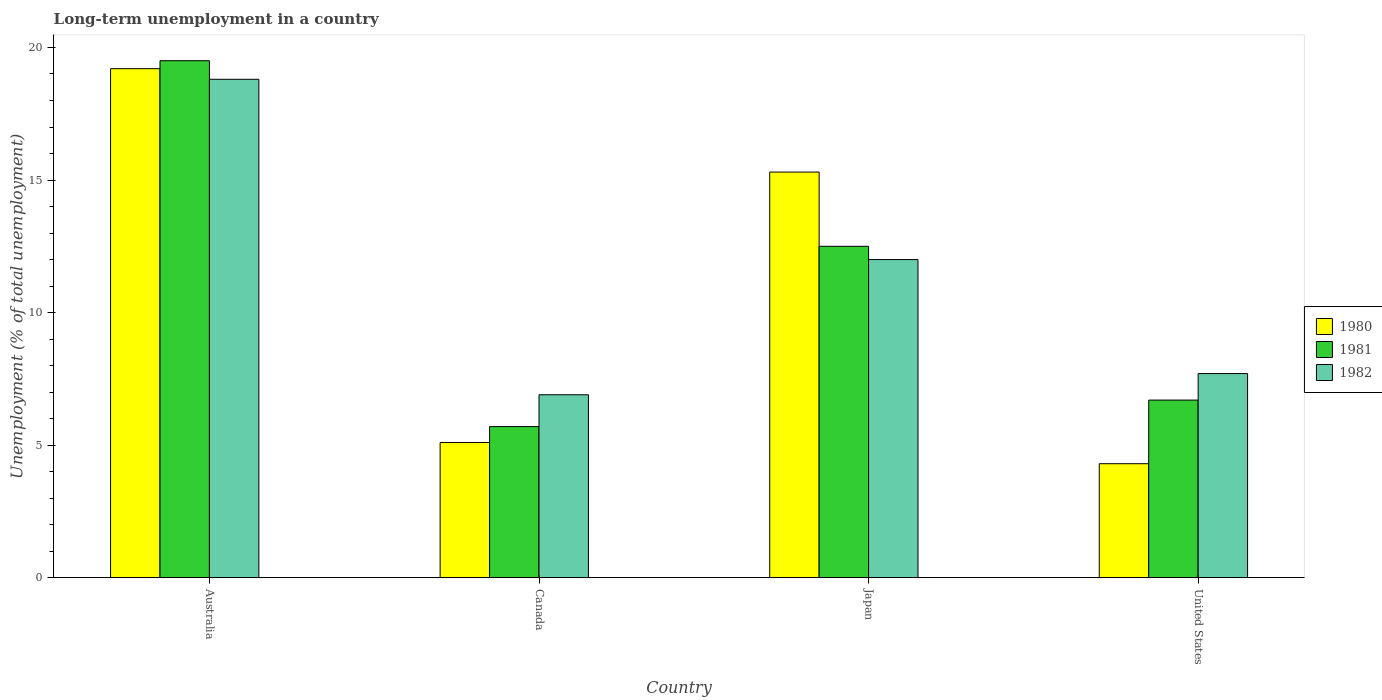How many different coloured bars are there?
Give a very brief answer. 3. How many groups of bars are there?
Provide a short and direct response. 4. Are the number of bars per tick equal to the number of legend labels?
Provide a short and direct response. Yes. How many bars are there on the 3rd tick from the left?
Your response must be concise. 3. How many bars are there on the 2nd tick from the right?
Give a very brief answer. 3. In how many cases, is the number of bars for a given country not equal to the number of legend labels?
Provide a short and direct response. 0. What is the percentage of long-term unemployed population in 1982 in Australia?
Offer a terse response. 18.8. Across all countries, what is the maximum percentage of long-term unemployed population in 1981?
Ensure brevity in your answer.  19.5. Across all countries, what is the minimum percentage of long-term unemployed population in 1981?
Offer a terse response. 5.7. What is the total percentage of long-term unemployed population in 1981 in the graph?
Your answer should be very brief. 44.4. What is the difference between the percentage of long-term unemployed population in 1982 in Canada and that in Japan?
Make the answer very short. -5.1. What is the difference between the percentage of long-term unemployed population in 1981 in Japan and the percentage of long-term unemployed population in 1982 in Canada?
Your answer should be very brief. 5.6. What is the average percentage of long-term unemployed population in 1982 per country?
Offer a very short reply. 11.35. What is the difference between the percentage of long-term unemployed population of/in 1982 and percentage of long-term unemployed population of/in 1980 in Canada?
Offer a very short reply. 1.8. In how many countries, is the percentage of long-term unemployed population in 1981 greater than 5 %?
Ensure brevity in your answer.  4. What is the ratio of the percentage of long-term unemployed population in 1981 in Australia to that in Japan?
Give a very brief answer. 1.56. Is the percentage of long-term unemployed population in 1982 in Australia less than that in Canada?
Your answer should be compact. No. What is the difference between the highest and the lowest percentage of long-term unemployed population in 1982?
Make the answer very short. 11.9. In how many countries, is the percentage of long-term unemployed population in 1981 greater than the average percentage of long-term unemployed population in 1981 taken over all countries?
Make the answer very short. 2. Is the sum of the percentage of long-term unemployed population in 1981 in Canada and United States greater than the maximum percentage of long-term unemployed population in 1980 across all countries?
Your answer should be very brief. No. What does the 2nd bar from the left in United States represents?
Your answer should be compact. 1981. Is it the case that in every country, the sum of the percentage of long-term unemployed population in 1981 and percentage of long-term unemployed population in 1982 is greater than the percentage of long-term unemployed population in 1980?
Offer a terse response. Yes. Are all the bars in the graph horizontal?
Offer a terse response. No. How many countries are there in the graph?
Give a very brief answer. 4. Are the values on the major ticks of Y-axis written in scientific E-notation?
Provide a short and direct response. No. Does the graph contain any zero values?
Your answer should be compact. No. Does the graph contain grids?
Your answer should be compact. No. Where does the legend appear in the graph?
Keep it short and to the point. Center right. How are the legend labels stacked?
Your response must be concise. Vertical. What is the title of the graph?
Offer a terse response. Long-term unemployment in a country. What is the label or title of the X-axis?
Offer a terse response. Country. What is the label or title of the Y-axis?
Your answer should be compact. Unemployment (% of total unemployment). What is the Unemployment (% of total unemployment) of 1980 in Australia?
Make the answer very short. 19.2. What is the Unemployment (% of total unemployment) of 1981 in Australia?
Make the answer very short. 19.5. What is the Unemployment (% of total unemployment) of 1982 in Australia?
Your answer should be compact. 18.8. What is the Unemployment (% of total unemployment) in 1980 in Canada?
Ensure brevity in your answer.  5.1. What is the Unemployment (% of total unemployment) in 1981 in Canada?
Provide a short and direct response. 5.7. What is the Unemployment (% of total unemployment) in 1982 in Canada?
Offer a very short reply. 6.9. What is the Unemployment (% of total unemployment) in 1980 in Japan?
Provide a short and direct response. 15.3. What is the Unemployment (% of total unemployment) in 1980 in United States?
Your response must be concise. 4.3. What is the Unemployment (% of total unemployment) of 1981 in United States?
Provide a succinct answer. 6.7. What is the Unemployment (% of total unemployment) of 1982 in United States?
Keep it short and to the point. 7.7. Across all countries, what is the maximum Unemployment (% of total unemployment) of 1980?
Offer a terse response. 19.2. Across all countries, what is the maximum Unemployment (% of total unemployment) of 1981?
Make the answer very short. 19.5. Across all countries, what is the maximum Unemployment (% of total unemployment) in 1982?
Keep it short and to the point. 18.8. Across all countries, what is the minimum Unemployment (% of total unemployment) of 1980?
Offer a very short reply. 4.3. Across all countries, what is the minimum Unemployment (% of total unemployment) of 1981?
Provide a short and direct response. 5.7. Across all countries, what is the minimum Unemployment (% of total unemployment) in 1982?
Make the answer very short. 6.9. What is the total Unemployment (% of total unemployment) of 1980 in the graph?
Provide a short and direct response. 43.9. What is the total Unemployment (% of total unemployment) in 1981 in the graph?
Keep it short and to the point. 44.4. What is the total Unemployment (% of total unemployment) in 1982 in the graph?
Offer a very short reply. 45.4. What is the difference between the Unemployment (% of total unemployment) in 1980 in Australia and that in Canada?
Make the answer very short. 14.1. What is the difference between the Unemployment (% of total unemployment) of 1982 in Australia and that in Japan?
Your answer should be very brief. 6.8. What is the difference between the Unemployment (% of total unemployment) of 1980 in Australia and that in United States?
Make the answer very short. 14.9. What is the difference between the Unemployment (% of total unemployment) of 1981 in Canada and that in Japan?
Your response must be concise. -6.8. What is the difference between the Unemployment (% of total unemployment) of 1982 in Canada and that in Japan?
Give a very brief answer. -5.1. What is the difference between the Unemployment (% of total unemployment) of 1980 in Canada and that in United States?
Give a very brief answer. 0.8. What is the difference between the Unemployment (% of total unemployment) of 1981 in Japan and that in United States?
Give a very brief answer. 5.8. What is the difference between the Unemployment (% of total unemployment) of 1980 in Australia and the Unemployment (% of total unemployment) of 1982 in Canada?
Your answer should be compact. 12.3. What is the difference between the Unemployment (% of total unemployment) in 1981 in Australia and the Unemployment (% of total unemployment) in 1982 in United States?
Your response must be concise. 11.8. What is the difference between the Unemployment (% of total unemployment) in 1980 in Canada and the Unemployment (% of total unemployment) in 1982 in United States?
Ensure brevity in your answer.  -2.6. What is the difference between the Unemployment (% of total unemployment) of 1981 in Canada and the Unemployment (% of total unemployment) of 1982 in United States?
Your answer should be very brief. -2. What is the difference between the Unemployment (% of total unemployment) of 1980 in Japan and the Unemployment (% of total unemployment) of 1982 in United States?
Provide a short and direct response. 7.6. What is the average Unemployment (% of total unemployment) of 1980 per country?
Provide a succinct answer. 10.97. What is the average Unemployment (% of total unemployment) in 1982 per country?
Your answer should be compact. 11.35. What is the difference between the Unemployment (% of total unemployment) of 1980 and Unemployment (% of total unemployment) of 1981 in Australia?
Your response must be concise. -0.3. What is the difference between the Unemployment (% of total unemployment) of 1980 and Unemployment (% of total unemployment) of 1982 in Canada?
Offer a terse response. -1.8. What is the difference between the Unemployment (% of total unemployment) of 1980 and Unemployment (% of total unemployment) of 1981 in Japan?
Make the answer very short. 2.8. What is the difference between the Unemployment (% of total unemployment) in 1980 and Unemployment (% of total unemployment) in 1982 in Japan?
Your answer should be very brief. 3.3. What is the difference between the Unemployment (% of total unemployment) in 1981 and Unemployment (% of total unemployment) in 1982 in Japan?
Keep it short and to the point. 0.5. What is the ratio of the Unemployment (% of total unemployment) in 1980 in Australia to that in Canada?
Your response must be concise. 3.76. What is the ratio of the Unemployment (% of total unemployment) of 1981 in Australia to that in Canada?
Make the answer very short. 3.42. What is the ratio of the Unemployment (% of total unemployment) of 1982 in Australia to that in Canada?
Provide a succinct answer. 2.72. What is the ratio of the Unemployment (% of total unemployment) of 1980 in Australia to that in Japan?
Make the answer very short. 1.25. What is the ratio of the Unemployment (% of total unemployment) in 1981 in Australia to that in Japan?
Provide a short and direct response. 1.56. What is the ratio of the Unemployment (% of total unemployment) of 1982 in Australia to that in Japan?
Offer a terse response. 1.57. What is the ratio of the Unemployment (% of total unemployment) in 1980 in Australia to that in United States?
Keep it short and to the point. 4.47. What is the ratio of the Unemployment (% of total unemployment) in 1981 in Australia to that in United States?
Provide a short and direct response. 2.91. What is the ratio of the Unemployment (% of total unemployment) of 1982 in Australia to that in United States?
Give a very brief answer. 2.44. What is the ratio of the Unemployment (% of total unemployment) in 1980 in Canada to that in Japan?
Offer a very short reply. 0.33. What is the ratio of the Unemployment (% of total unemployment) in 1981 in Canada to that in Japan?
Give a very brief answer. 0.46. What is the ratio of the Unemployment (% of total unemployment) of 1982 in Canada to that in Japan?
Your answer should be very brief. 0.57. What is the ratio of the Unemployment (% of total unemployment) in 1980 in Canada to that in United States?
Give a very brief answer. 1.19. What is the ratio of the Unemployment (% of total unemployment) of 1981 in Canada to that in United States?
Offer a very short reply. 0.85. What is the ratio of the Unemployment (% of total unemployment) in 1982 in Canada to that in United States?
Ensure brevity in your answer.  0.9. What is the ratio of the Unemployment (% of total unemployment) in 1980 in Japan to that in United States?
Make the answer very short. 3.56. What is the ratio of the Unemployment (% of total unemployment) of 1981 in Japan to that in United States?
Keep it short and to the point. 1.87. What is the ratio of the Unemployment (% of total unemployment) of 1982 in Japan to that in United States?
Give a very brief answer. 1.56. What is the difference between the highest and the second highest Unemployment (% of total unemployment) of 1980?
Your response must be concise. 3.9. What is the difference between the highest and the second highest Unemployment (% of total unemployment) in 1981?
Keep it short and to the point. 7. What is the difference between the highest and the second highest Unemployment (% of total unemployment) in 1982?
Provide a short and direct response. 6.8. What is the difference between the highest and the lowest Unemployment (% of total unemployment) of 1980?
Offer a terse response. 14.9. What is the difference between the highest and the lowest Unemployment (% of total unemployment) of 1981?
Your response must be concise. 13.8. 